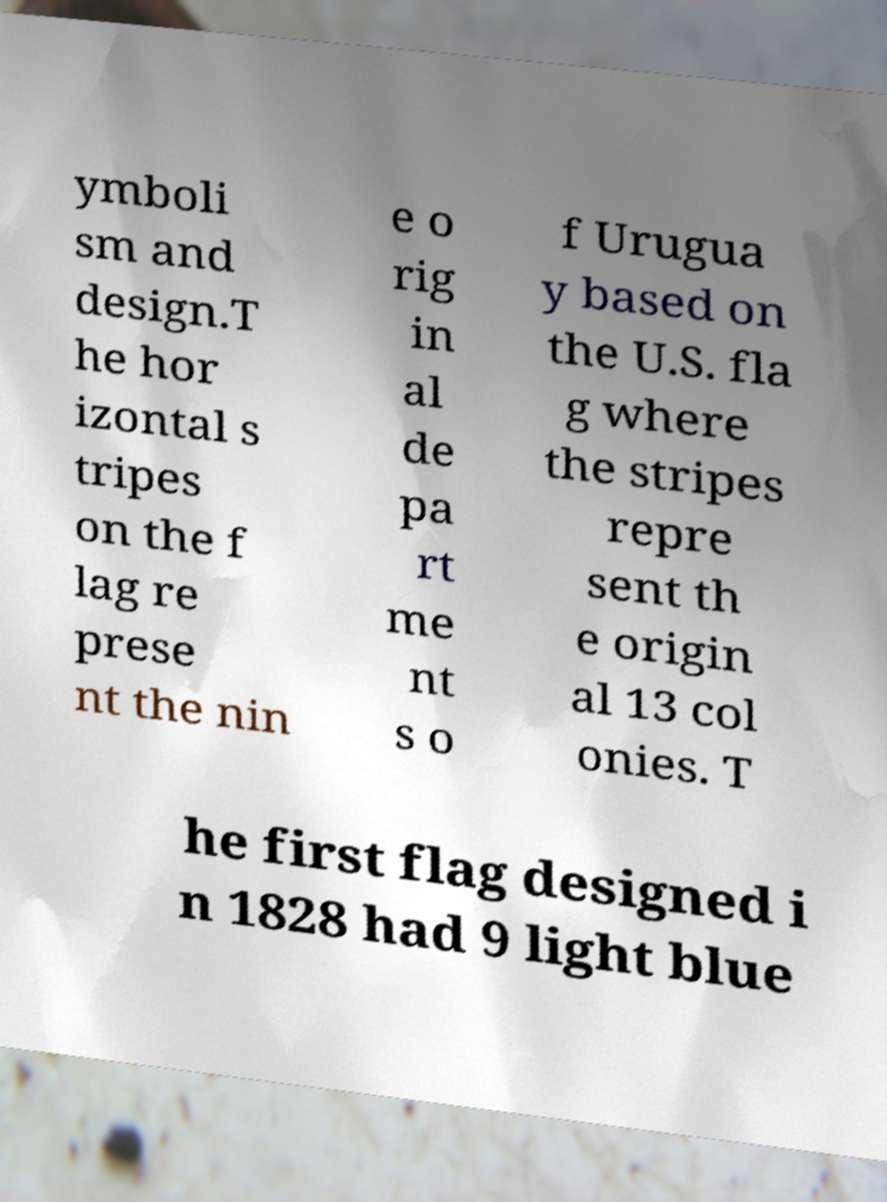For documentation purposes, I need the text within this image transcribed. Could you provide that? ymboli sm and design.T he hor izontal s tripes on the f lag re prese nt the nin e o rig in al de pa rt me nt s o f Urugua y based on the U.S. fla g where the stripes repre sent th e origin al 13 col onies. T he first flag designed i n 1828 had 9 light blue 